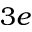<formula> <loc_0><loc_0><loc_500><loc_500>3 e</formula> 